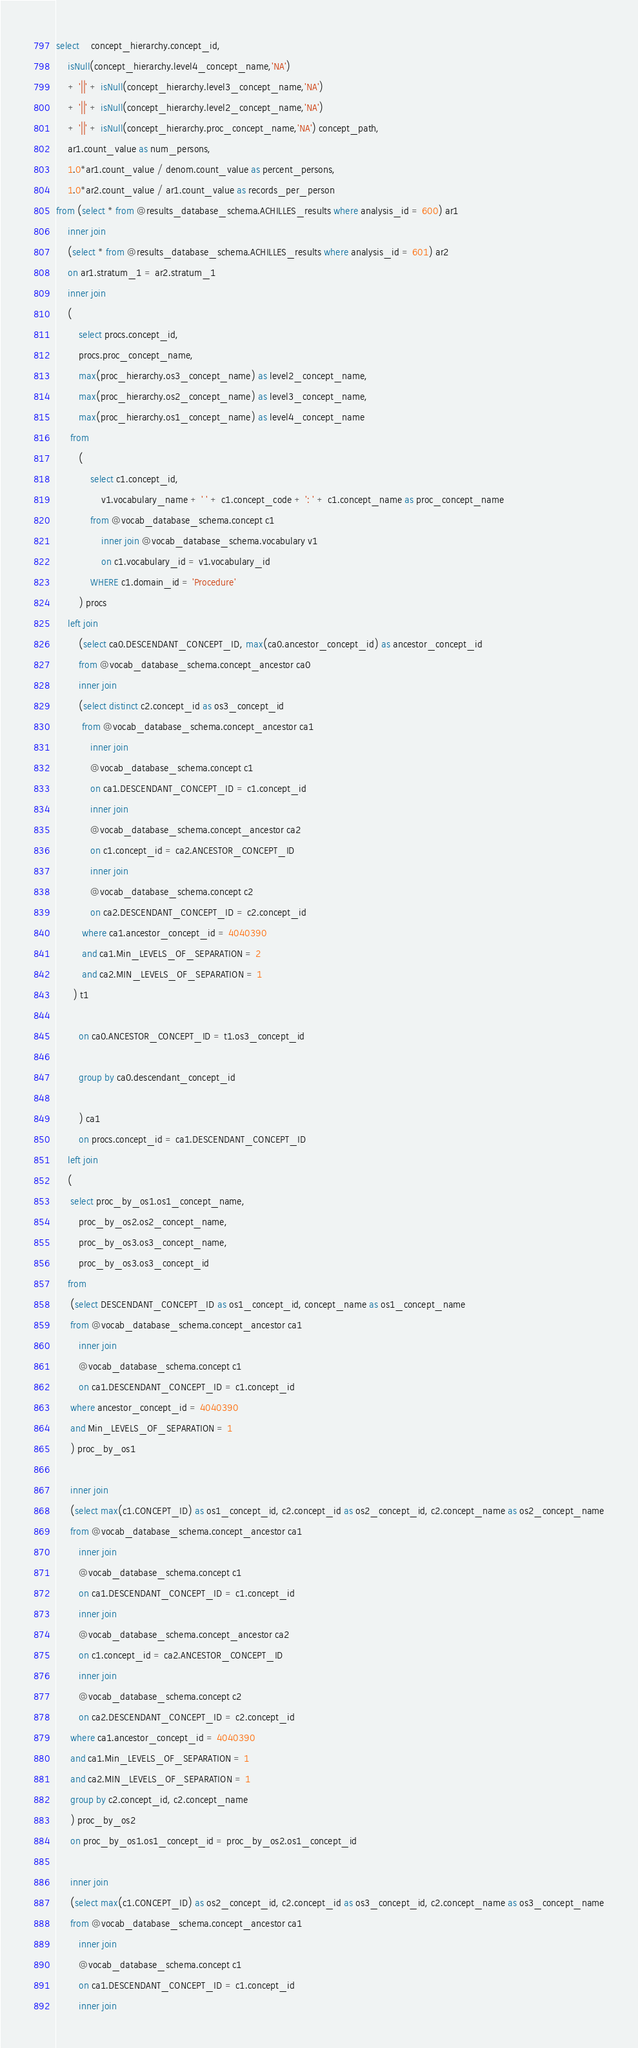Convert code to text. <code><loc_0><loc_0><loc_500><loc_500><_SQL_>select 	concept_hierarchy.concept_id,
	isNull(concept_hierarchy.level4_concept_name,'NA') 
	+ '||' + isNull(concept_hierarchy.level3_concept_name,'NA') 
	+ '||' + isNull(concept_hierarchy.level2_concept_name,'NA') 
	+ '||' + isNull(concept_hierarchy.proc_concept_name,'NA') concept_path,
	ar1.count_value as num_persons, 
	1.0*ar1.count_value / denom.count_value as percent_persons,
	1.0*ar2.count_value / ar1.count_value as records_per_person
from (select * from @results_database_schema.ACHILLES_results where analysis_id = 600) ar1
	inner join
	(select * from @results_database_schema.ACHILLES_results where analysis_id = 601) ar2
	on ar1.stratum_1 = ar2.stratum_1
	inner join
	(
		select procs.concept_id,
		procs.proc_concept_name,
		max(proc_hierarchy.os3_concept_name) as level2_concept_name,
		max(proc_hierarchy.os2_concept_name) as level3_concept_name,
		max(proc_hierarchy.os1_concept_name) as level4_concept_name
	 from
		(
			select c1.concept_id, 
				v1.vocabulary_name + ' ' + c1.concept_code + ': ' + c1.concept_name as proc_concept_name
			from @vocab_database_schema.concept c1
				inner join @vocab_database_schema.vocabulary v1
				on c1.vocabulary_id = v1.vocabulary_id
			WHERE c1.domain_id = 'Procedure'
		) procs
	left join
		(select ca0.DESCENDANT_CONCEPT_ID, max(ca0.ancestor_concept_id) as ancestor_concept_id
		from @vocab_database_schema.concept_ancestor ca0
		inner join
		(select distinct c2.concept_id as os3_concept_id
		 from @vocab_database_schema.concept_ancestor ca1
			inner join
			@vocab_database_schema.concept c1
			on ca1.DESCENDANT_CONCEPT_ID = c1.concept_id
			inner join
			@vocab_database_schema.concept_ancestor ca2
			on c1.concept_id = ca2.ANCESTOR_CONCEPT_ID
			inner join
			@vocab_database_schema.concept c2
			on ca2.DESCENDANT_CONCEPT_ID = c2.concept_id
		 where ca1.ancestor_concept_id = 4040390
		 and ca1.Min_LEVELS_OF_SEPARATION = 2
		 and ca2.MIN_LEVELS_OF_SEPARATION = 1
	  ) t1
	
		on ca0.ANCESTOR_CONCEPT_ID = t1.os3_concept_id

		group by ca0.descendant_concept_id

		) ca1
		on procs.concept_id = ca1.DESCENDANT_CONCEPT_ID
	left join
	(
	 select proc_by_os1.os1_concept_name,
		proc_by_os2.os2_concept_name,
		proc_by_os3.os3_concept_name,
		proc_by_os3.os3_concept_id
	from
	 (select DESCENDANT_CONCEPT_ID as os1_concept_id, concept_name as os1_concept_name
	 from @vocab_database_schema.concept_ancestor ca1
		inner join
		@vocab_database_schema.concept c1
		on ca1.DESCENDANT_CONCEPT_ID = c1.concept_id
	 where ancestor_concept_id = 4040390
	 and Min_LEVELS_OF_SEPARATION = 1
	 ) proc_by_os1

	 inner join
	 (select max(c1.CONCEPT_ID) as os1_concept_id, c2.concept_id as os2_concept_id, c2.concept_name as os2_concept_name
	 from @vocab_database_schema.concept_ancestor ca1
		inner join
		@vocab_database_schema.concept c1
		on ca1.DESCENDANT_CONCEPT_ID = c1.concept_id
		inner join
		@vocab_database_schema.concept_ancestor ca2
		on c1.concept_id = ca2.ANCESTOR_CONCEPT_ID
		inner join
		@vocab_database_schema.concept c2
		on ca2.DESCENDANT_CONCEPT_ID = c2.concept_id
	 where ca1.ancestor_concept_id = 4040390
	 and ca1.Min_LEVELS_OF_SEPARATION = 1
	 and ca2.MIN_LEVELS_OF_SEPARATION = 1
	 group by c2.concept_id, c2.concept_name
	 ) proc_by_os2
	 on proc_by_os1.os1_concept_id = proc_by_os2.os1_concept_id

	 inner join
	 (select max(c1.CONCEPT_ID) as os2_concept_id, c2.concept_id as os3_concept_id, c2.concept_name as os3_concept_name
	 from @vocab_database_schema.concept_ancestor ca1
		inner join
		@vocab_database_schema.concept c1
		on ca1.DESCENDANT_CONCEPT_ID = c1.concept_id
		inner join</code> 